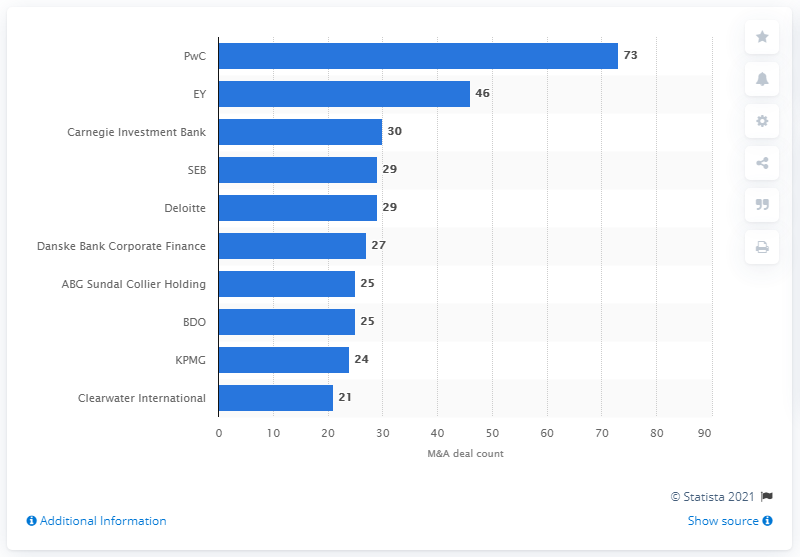Identify some key points in this picture. PriceWaterhouseCoopers had 73 deals in 2016. 